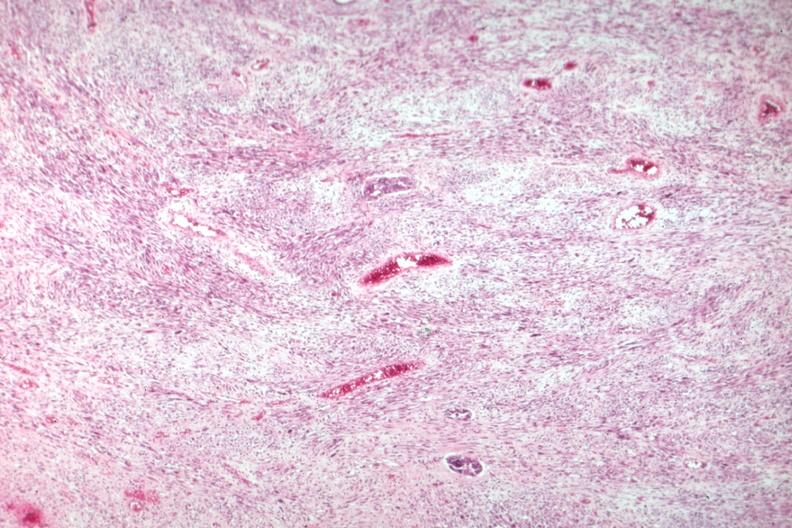does this image show nice view of tumor primarily stromal element?
Answer the question using a single word or phrase. Yes 